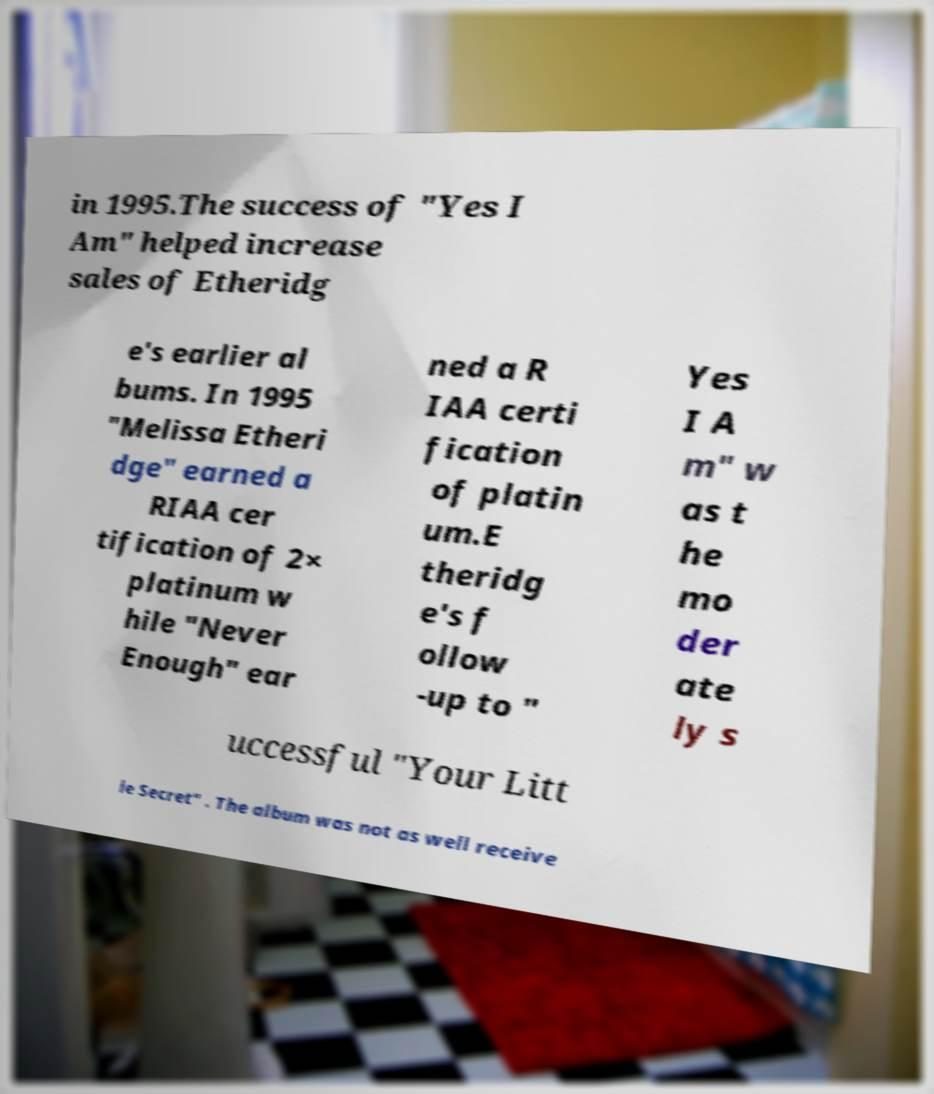I need the written content from this picture converted into text. Can you do that? in 1995.The success of "Yes I Am" helped increase sales of Etheridg e's earlier al bums. In 1995 "Melissa Etheri dge" earned a RIAA cer tification of 2× platinum w hile "Never Enough" ear ned a R IAA certi fication of platin um.E theridg e's f ollow -up to " Yes I A m" w as t he mo der ate ly s uccessful "Your Litt le Secret" . The album was not as well receive 